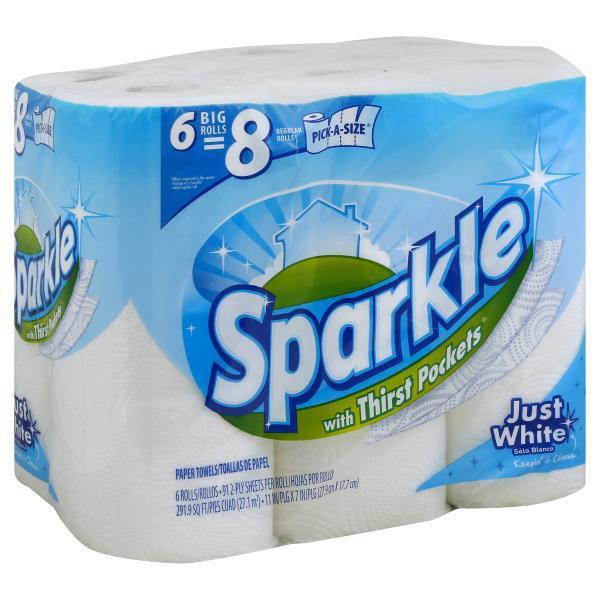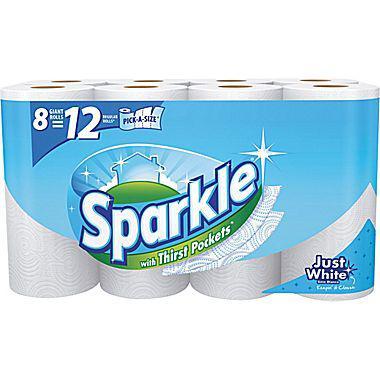The first image is the image on the left, the second image is the image on the right. Evaluate the accuracy of this statement regarding the images: "There are six rolls of paper towel in the package in the image on the left.". Is it true? Answer yes or no. Yes. The first image is the image on the left, the second image is the image on the right. Examine the images to the left and right. Is the description "One image features a single package of six rolls in two rows of three." accurate? Answer yes or no. Yes. 